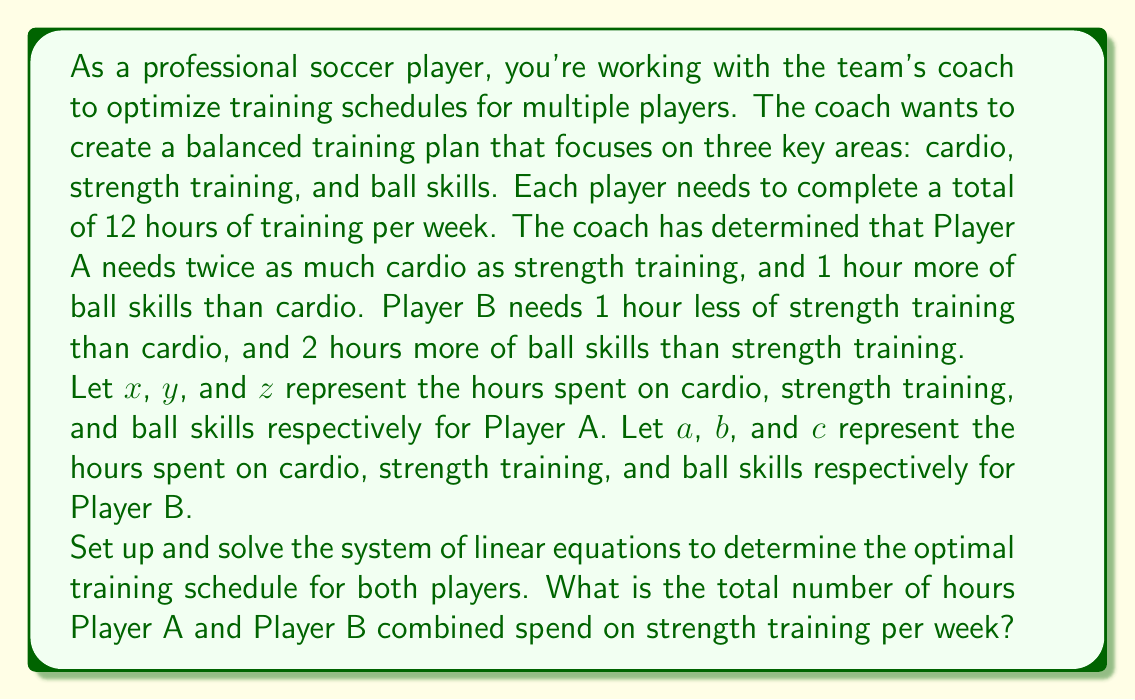Give your solution to this math problem. Let's approach this problem step by step:

1) First, let's set up the equations for Player A:

   $x + y + z = 12$ (total training hours)
   $x = 2y$ (twice as much cardio as strength training)
   $z = x + 1$ (1 hour more of ball skills than cardio)

2) Now, let's set up the equations for Player B:

   $a + b + c = 12$ (total training hours)
   $a = b + 1$ (1 hour less of strength training than cardio)
   $c = b + 2$ (2 hours more of ball skills than strength training)

3) Let's solve for Player A first:
   From $x = 2y$ and $z = x + 1$, we can substitute into the first equation:
   
   $2y + y + (2y + 1) = 12$
   $5y + 1 = 12$
   $5y = 11$
   $y = \frac{11}{5} = 2.2$

   So, $x = 2y = 4.4$ and $z = x + 1 = 5.4$

4) Now for Player B:
   From $a = b + 1$ and $c = b + 2$, we can substitute into the first equation:
   
   $(b + 1) + b + (b + 2) = 12$
   $3b + 3 = 12$
   $3b = 9$
   $b = 3$

   So, $a = b + 1 = 4$ and $c = b + 2 = 5$

5) The question asks for the total number of hours both players spend on strength training.
   For Player A, this is $y = 2.2$ hours.
   For Player B, this is $b = 3$ hours.

   The total is $2.2 + 3 = 5.2$ hours.
Answer: $5.2$ hours 